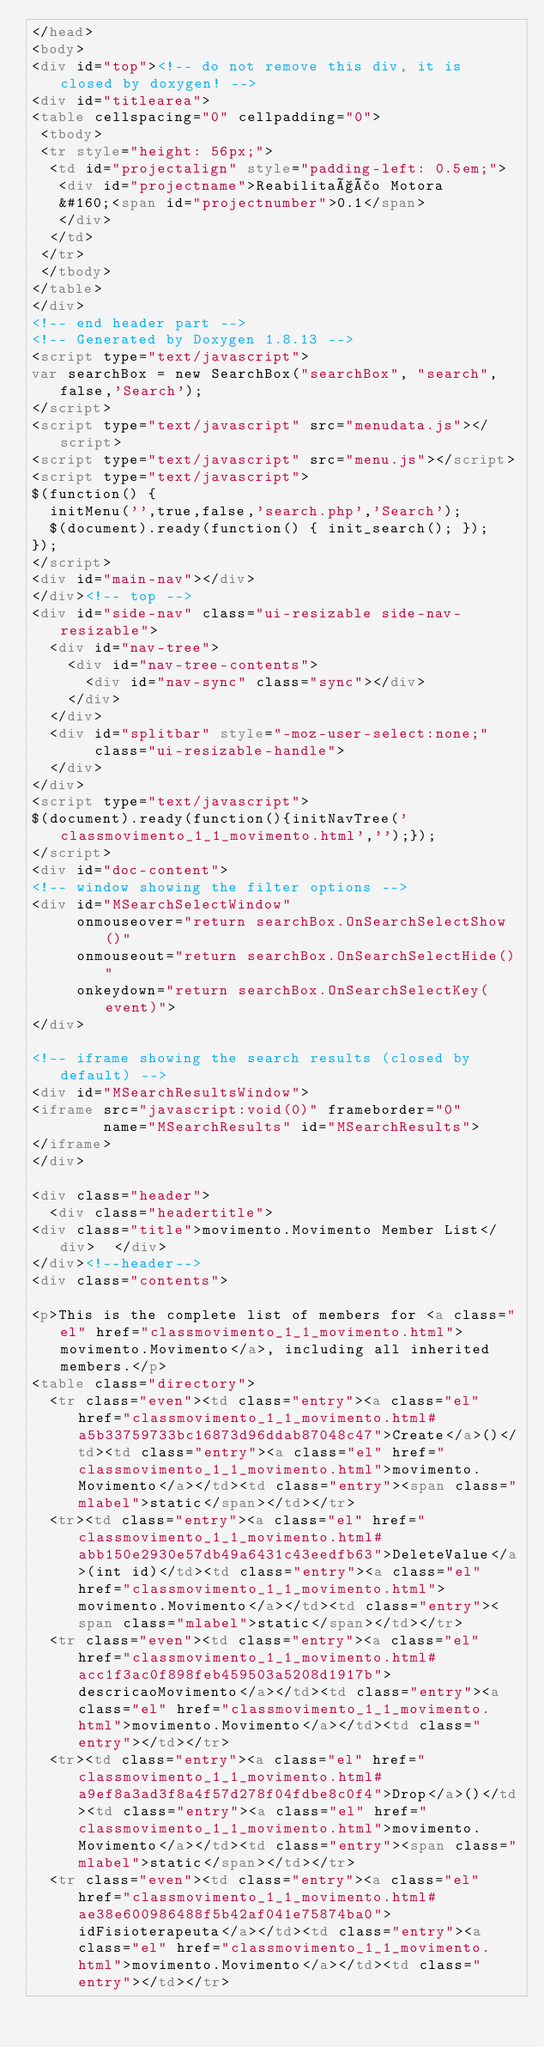Convert code to text. <code><loc_0><loc_0><loc_500><loc_500><_HTML_></head>
<body>
<div id="top"><!-- do not remove this div, it is closed by doxygen! -->
<div id="titlearea">
<table cellspacing="0" cellpadding="0">
 <tbody>
 <tr style="height: 56px;">
  <td id="projectalign" style="padding-left: 0.5em;">
   <div id="projectname">Reabilitação Motora
   &#160;<span id="projectnumber">0.1</span>
   </div>
  </td>
 </tr>
 </tbody>
</table>
</div>
<!-- end header part -->
<!-- Generated by Doxygen 1.8.13 -->
<script type="text/javascript">
var searchBox = new SearchBox("searchBox", "search",false,'Search');
</script>
<script type="text/javascript" src="menudata.js"></script>
<script type="text/javascript" src="menu.js"></script>
<script type="text/javascript">
$(function() {
  initMenu('',true,false,'search.php','Search');
  $(document).ready(function() { init_search(); });
});
</script>
<div id="main-nav"></div>
</div><!-- top -->
<div id="side-nav" class="ui-resizable side-nav-resizable">
  <div id="nav-tree">
    <div id="nav-tree-contents">
      <div id="nav-sync" class="sync"></div>
    </div>
  </div>
  <div id="splitbar" style="-moz-user-select:none;" 
       class="ui-resizable-handle">
  </div>
</div>
<script type="text/javascript">
$(document).ready(function(){initNavTree('classmovimento_1_1_movimento.html','');});
</script>
<div id="doc-content">
<!-- window showing the filter options -->
<div id="MSearchSelectWindow"
     onmouseover="return searchBox.OnSearchSelectShow()"
     onmouseout="return searchBox.OnSearchSelectHide()"
     onkeydown="return searchBox.OnSearchSelectKey(event)">
</div>

<!-- iframe showing the search results (closed by default) -->
<div id="MSearchResultsWindow">
<iframe src="javascript:void(0)" frameborder="0" 
        name="MSearchResults" id="MSearchResults">
</iframe>
</div>

<div class="header">
  <div class="headertitle">
<div class="title">movimento.Movimento Member List</div>  </div>
</div><!--header-->
<div class="contents">

<p>This is the complete list of members for <a class="el" href="classmovimento_1_1_movimento.html">movimento.Movimento</a>, including all inherited members.</p>
<table class="directory">
  <tr class="even"><td class="entry"><a class="el" href="classmovimento_1_1_movimento.html#a5b33759733bc16873d96ddab87048c47">Create</a>()</td><td class="entry"><a class="el" href="classmovimento_1_1_movimento.html">movimento.Movimento</a></td><td class="entry"><span class="mlabel">static</span></td></tr>
  <tr><td class="entry"><a class="el" href="classmovimento_1_1_movimento.html#abb150e2930e57db49a6431c43eedfb63">DeleteValue</a>(int id)</td><td class="entry"><a class="el" href="classmovimento_1_1_movimento.html">movimento.Movimento</a></td><td class="entry"><span class="mlabel">static</span></td></tr>
  <tr class="even"><td class="entry"><a class="el" href="classmovimento_1_1_movimento.html#acc1f3ac0f898feb459503a5208d1917b">descricaoMovimento</a></td><td class="entry"><a class="el" href="classmovimento_1_1_movimento.html">movimento.Movimento</a></td><td class="entry"></td></tr>
  <tr><td class="entry"><a class="el" href="classmovimento_1_1_movimento.html#a9ef8a3ad3f8a4f57d278f04fdbe8c0f4">Drop</a>()</td><td class="entry"><a class="el" href="classmovimento_1_1_movimento.html">movimento.Movimento</a></td><td class="entry"><span class="mlabel">static</span></td></tr>
  <tr class="even"><td class="entry"><a class="el" href="classmovimento_1_1_movimento.html#ae38e600986488f5b42af041e75874ba0">idFisioterapeuta</a></td><td class="entry"><a class="el" href="classmovimento_1_1_movimento.html">movimento.Movimento</a></td><td class="entry"></td></tr></code> 